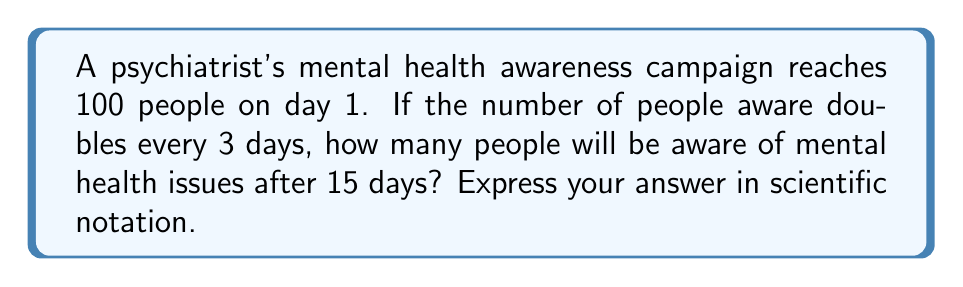Show me your answer to this math problem. Let's approach this step-by-step:

1) First, we need to identify the key components of the exponential growth model:
   - Initial value (a): 100 people
   - Growth factor (r): 2 (doubles every 3 days)
   - Time (t): 15 days

2) The general formula for exponential growth is:

   $$ P(t) = a \cdot r^{t/k} $$

   Where:
   - P(t) is the population at time t
   - a is the initial population
   - r is the growth factor
   - t is the time
   - k is the time interval for each growth

3) In this case, k = 3 because the population doubles every 3 days.

4) Plugging in our values:

   $$ P(15) = 100 \cdot 2^{15/3} $$

5) Simplify the exponent:

   $$ P(15) = 100 \cdot 2^5 $$

6) Calculate $2^5$:

   $$ P(15) = 100 \cdot 32 = 3200 $$

7) Convert to scientific notation:

   $$ P(15) = 3.2 \times 10^3 $$

Thus, after 15 days, 3200 people, or $3.2 \times 10^3$ in scientific notation, will be aware of mental health issues.
Answer: $3.2 \times 10^3$ 